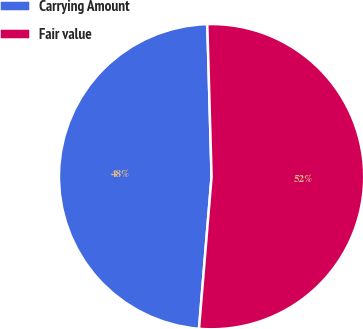Convert chart. <chart><loc_0><loc_0><loc_500><loc_500><pie_chart><fcel>Carrying Amount<fcel>Fair value<nl><fcel>48.24%<fcel>51.76%<nl></chart> 